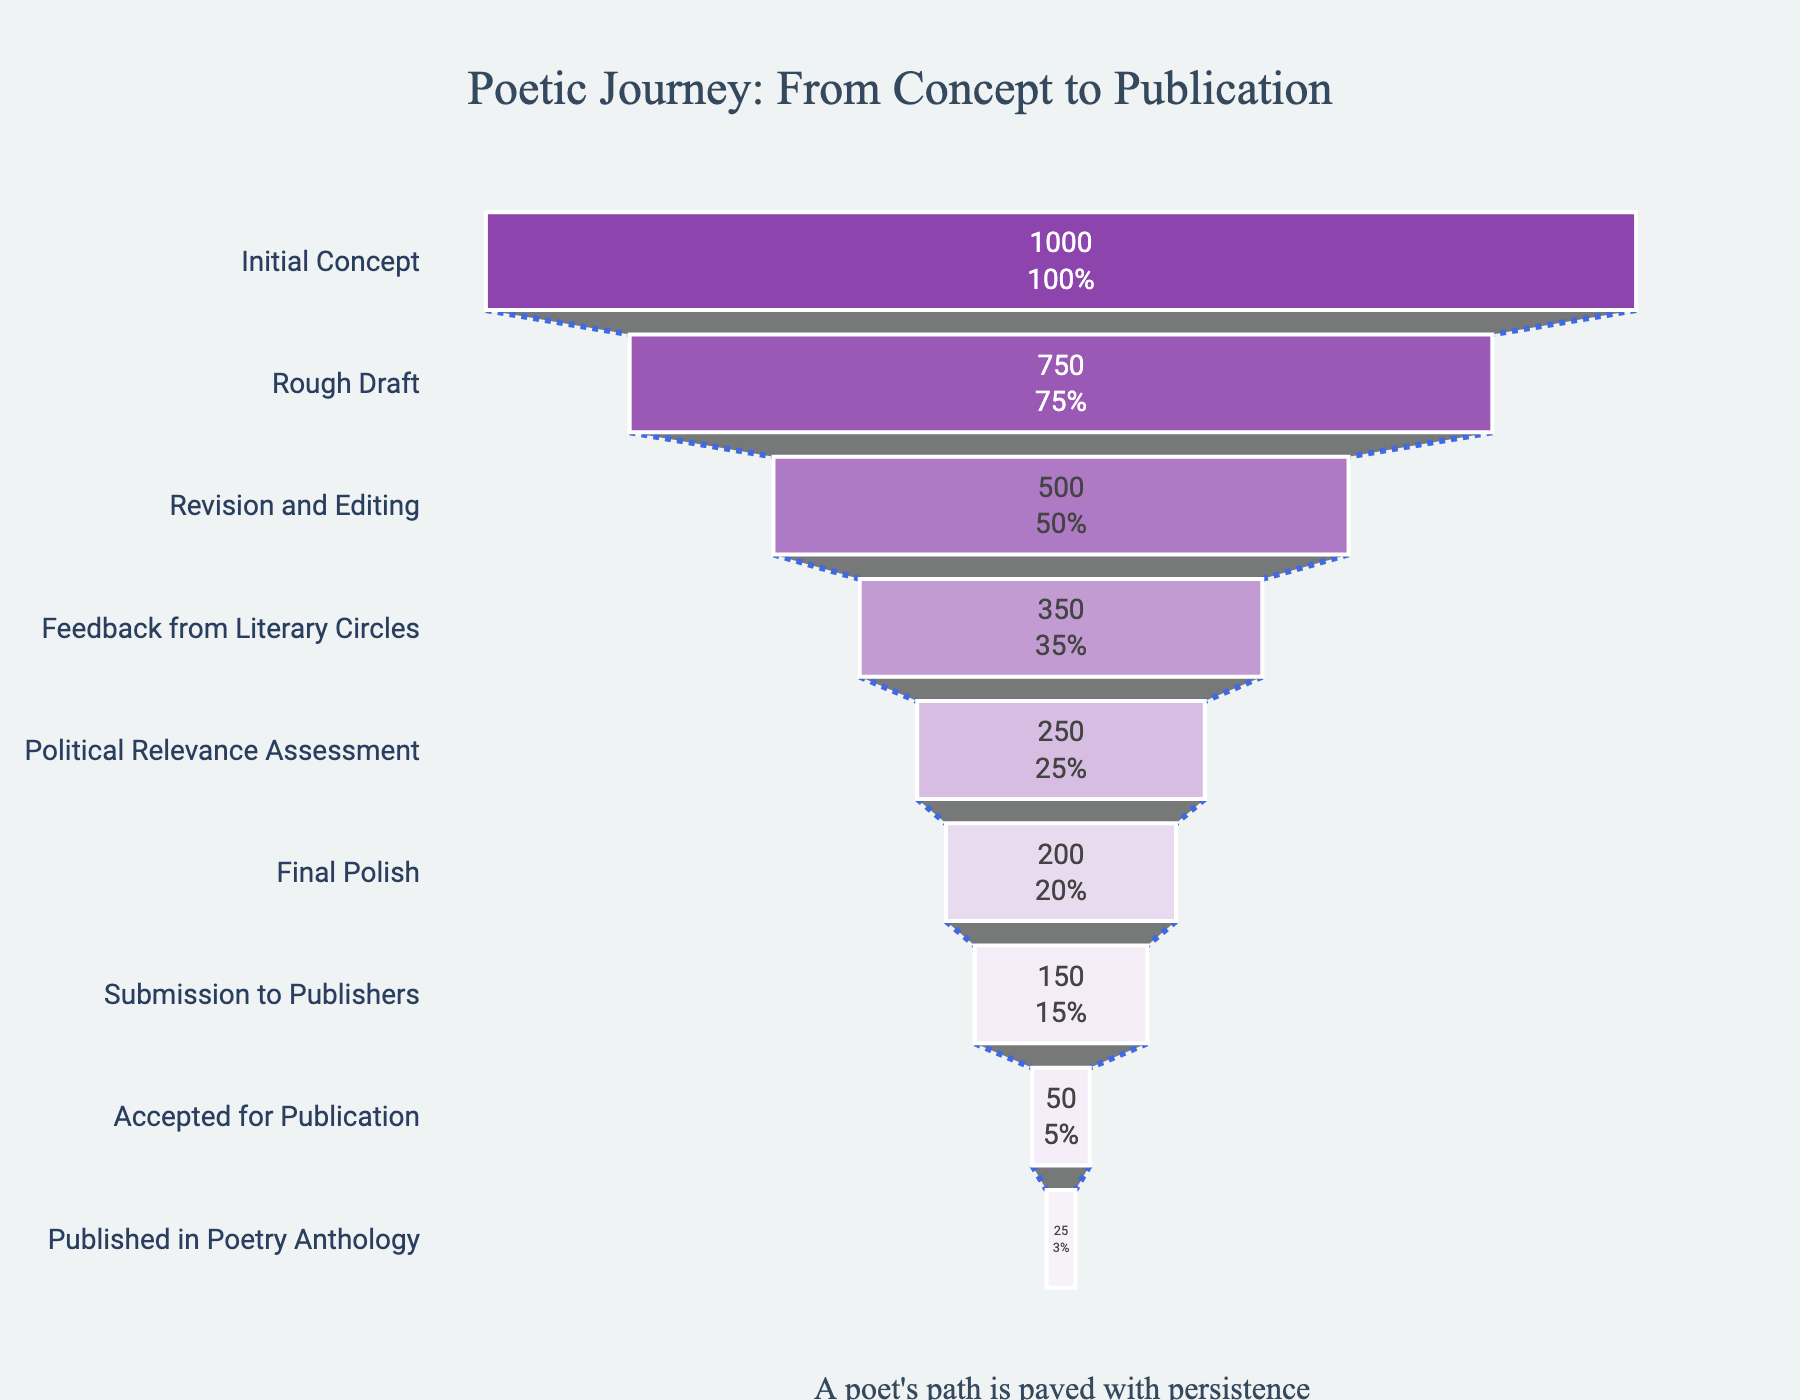What is the title of the funnel chart? The title is prominently displayed at the top of the chart.
Answer: Poetic Journey: From Concept to Publication How many stages are there in the funnel chart? Each unique "Stage" is a different step in the funnel process.
Answer: 9 What is the initial count of poetic concepts? The initial count is displayed for the "Initial Concept" stage.
Answer: 1000 How many poems make it to the "Final Polish" stage? The count for the "Final Polish" stage is directly indicated.
Answer: 200 How much attrition occurs between the "Rough Draft" and the "Feedback from Literary Circles" stages? Subtract the count at "Feedback from Literary Circles" from the count at "Rough Draft" to find the number lost. The counts are 750 (Rough Draft) and 350 (Feedback from Literary Circles).
Answer: 400 What percentage of initial concepts make it to the "Political Relevance Assessment" stage? Find the percentage by dividing the count at "Political Relevance Assessment" by the initial count and multiply by 100. The counts are 250 (Political Relevance Assessment) and 1000 (Initial Concept). Calculation: (250/1000) * 100
Answer: 25% Which stage has the highest attrition rate? Calculate the attrition rate for each stage as the percentage difference between stages. Compare these rates and determine which is the highest.
Answer: Rough Draft to Revision and Editing How many poems get accepted for publication but not published in the anthology? Subtract the count at "Published in Poetry Anthology" from the count at "Accepted for Publication." The counts are 50 (Accepted for Publication) and 25 (Published in Poetry Anthology).
Answer: 25 What insight does the annotation at the bottom provide about the journey? The annotation text provides a concluding summary of the whole process illustrated by the chart.
Answer: A poet's path is paved with persistence 